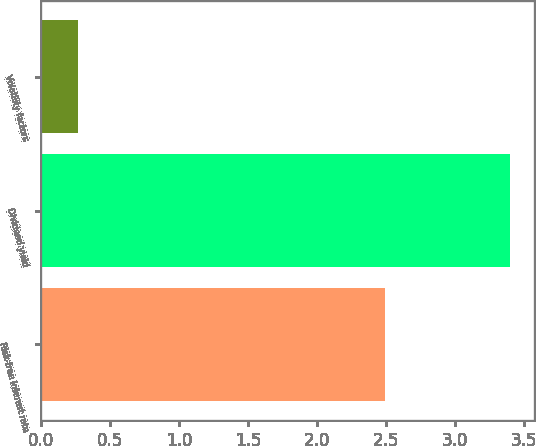Convert chart to OTSL. <chart><loc_0><loc_0><loc_500><loc_500><bar_chart><fcel>Risk-free interest rate<fcel>Dividend yield<fcel>Volatility factors<nl><fcel>2.49<fcel>3.4<fcel>0.27<nl></chart> 